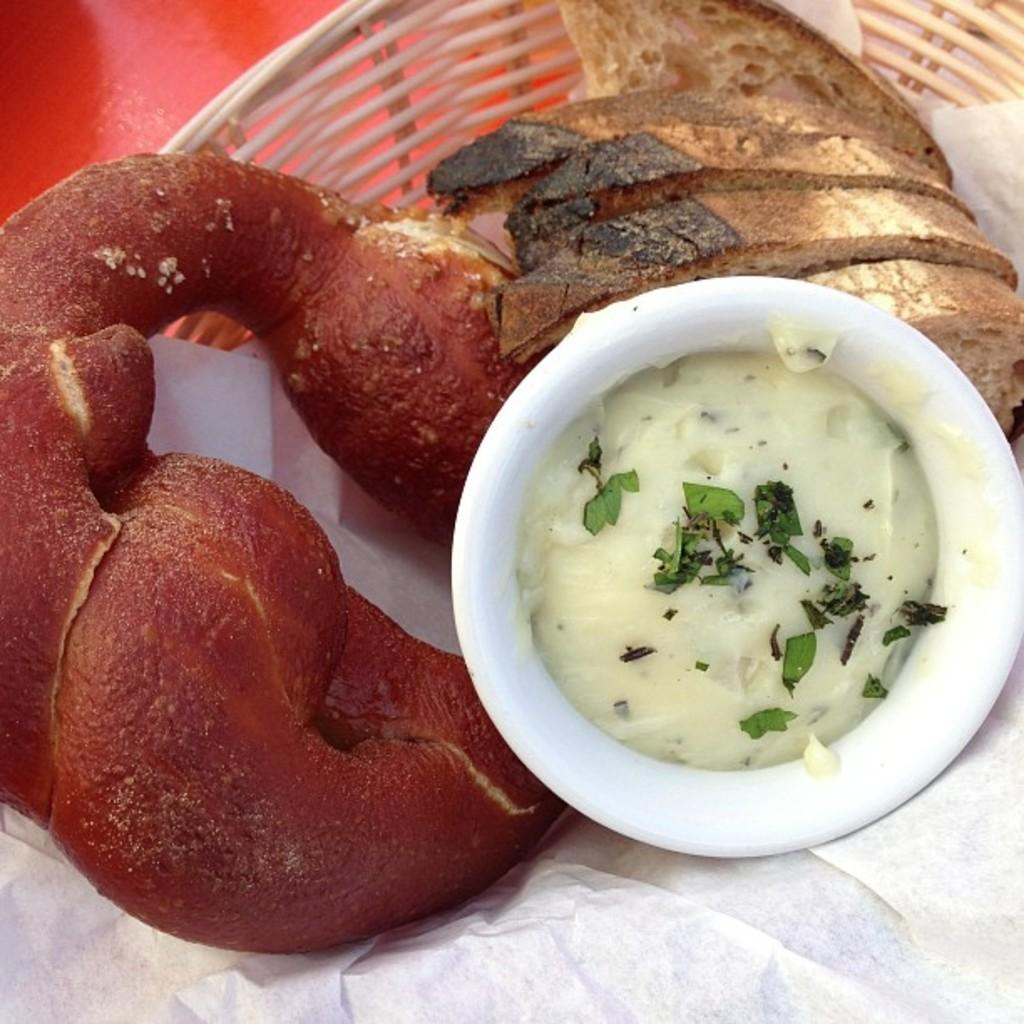What is contained in the basket in the image? There are food items in a basket in the image. What is present at the bottom of the image? There is tissue at the bottom of the image. How many crayons are visible in the image? There are no crayons present in the image. What type of mine is depicted in the image? There is no mine present in the image. 